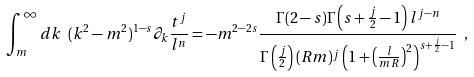Convert formula to latex. <formula><loc_0><loc_0><loc_500><loc_500>\int _ { m } ^ { \infty } d k \ ( k ^ { 2 } - m ^ { 2 } ) ^ { 1 - s } \partial _ { k } \frac { t ^ { j } } { l ^ { n } } = - m ^ { 2 - 2 s } \frac { \Gamma ( 2 - s ) \Gamma \left ( s + \frac { j } { 2 } - 1 \right ) l ^ { j - n } } { \Gamma \left ( \frac { j } { 2 } \right ) ( R m ) ^ { j } \left ( 1 + \left ( \frac { l } { m R } \right ) ^ { 2 } \right ) ^ { s + \frac { j } { 2 } - 1 } } \ ,</formula> 